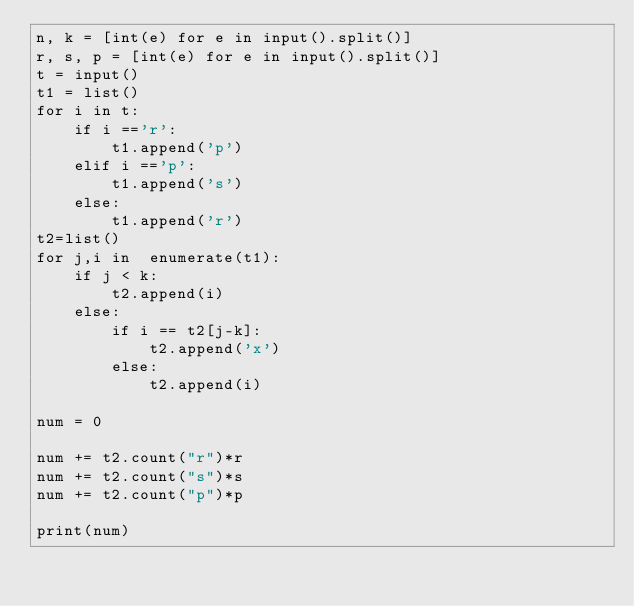Convert code to text. <code><loc_0><loc_0><loc_500><loc_500><_Python_>n, k = [int(e) for e in input().split()]
r, s, p = [int(e) for e in input().split()]
t = input()
t1 = list()
for i in t:
    if i =='r':
        t1.append('p')
    elif i =='p':
        t1.append('s')
    else:
        t1.append('r')
t2=list()
for j,i in  enumerate(t1):
    if j < k:
        t2.append(i)
    else:
        if i == t2[j-k]:
            t2.append('x')
        else:
            t2.append(i)

num = 0

num += t2.count("r")*r
num += t2.count("s")*s
num += t2.count("p")*p

print(num)</code> 